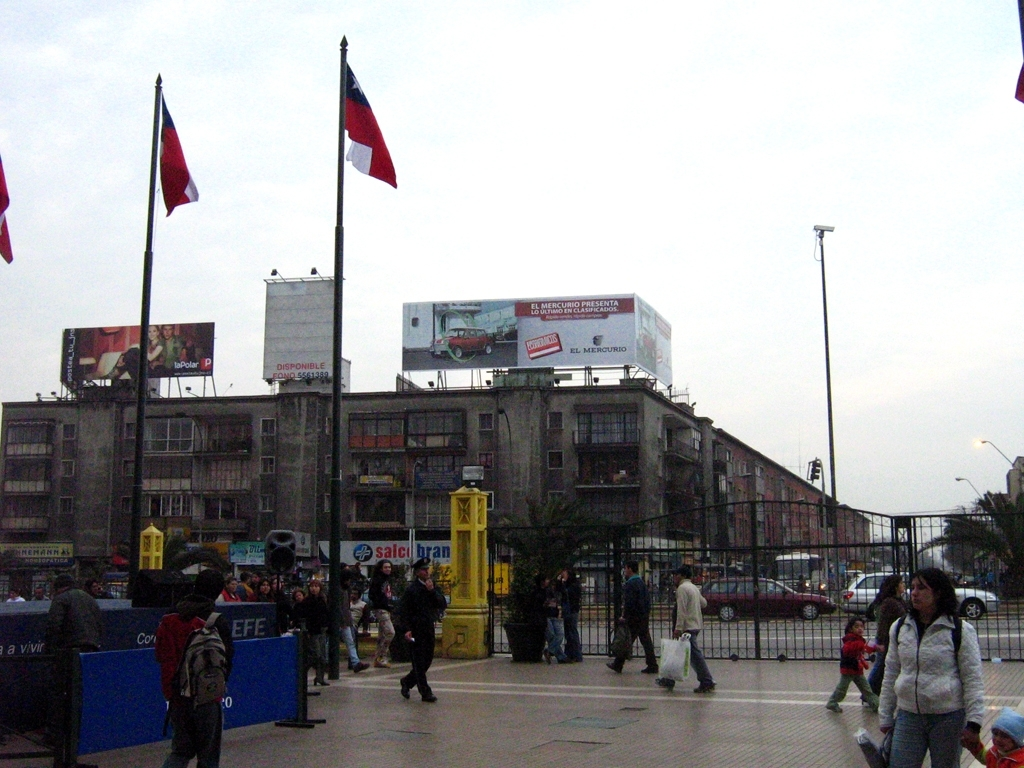What does this image suggest about the place it's depicting? This image shows a bustling cityscape with commercial advertisements, indicating an urban center likely bustling with economic activities. The presence of national flags may suggest a central or significant location within the city, maybe even a district known for its shopping or cultural importance. 